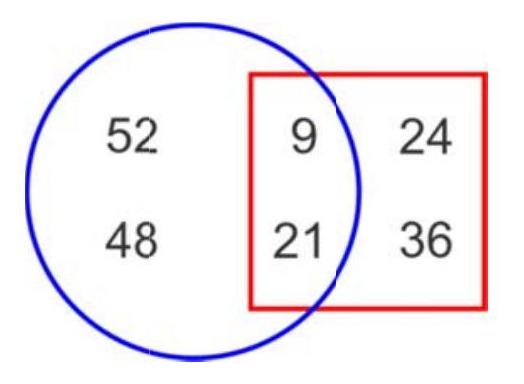How many numbers are outside the square? There are exactly two numbers outside the square, which are 52 and 48, both located within the blue circle but outside the red square. 